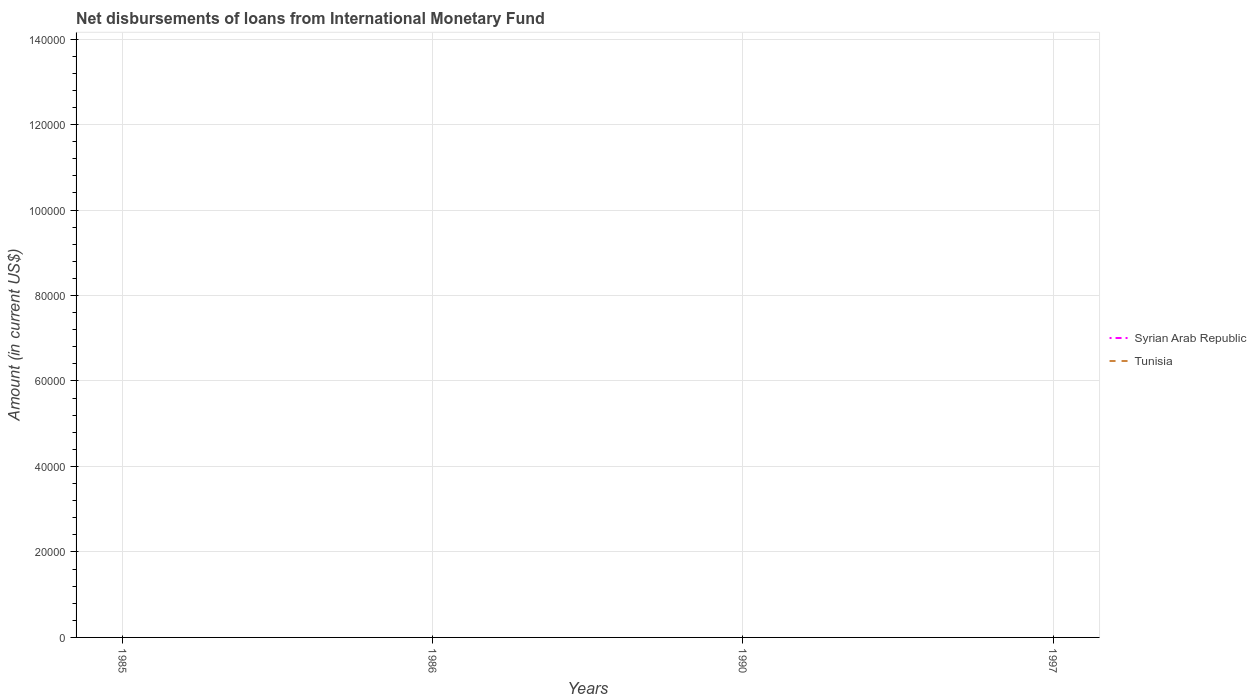Is the number of lines equal to the number of legend labels?
Ensure brevity in your answer.  No. What is the difference between the highest and the lowest amount of loans disbursed in Tunisia?
Offer a very short reply. 0. How many lines are there?
Give a very brief answer. 0. What is the difference between two consecutive major ticks on the Y-axis?
Offer a terse response. 2.00e+04. Are the values on the major ticks of Y-axis written in scientific E-notation?
Your response must be concise. No. Does the graph contain any zero values?
Provide a short and direct response. Yes. Does the graph contain grids?
Your answer should be very brief. Yes. Where does the legend appear in the graph?
Provide a short and direct response. Center right. How many legend labels are there?
Your answer should be very brief. 2. What is the title of the graph?
Your response must be concise. Net disbursements of loans from International Monetary Fund. Does "Other small states" appear as one of the legend labels in the graph?
Keep it short and to the point. No. What is the label or title of the Y-axis?
Ensure brevity in your answer.  Amount (in current US$). What is the Amount (in current US$) of Tunisia in 1986?
Keep it short and to the point. 0. What is the Amount (in current US$) of Syrian Arab Republic in 1990?
Make the answer very short. 0. What is the Amount (in current US$) in Tunisia in 1990?
Keep it short and to the point. 0. What is the total Amount (in current US$) in Tunisia in the graph?
Keep it short and to the point. 0. What is the average Amount (in current US$) in Syrian Arab Republic per year?
Your response must be concise. 0. 